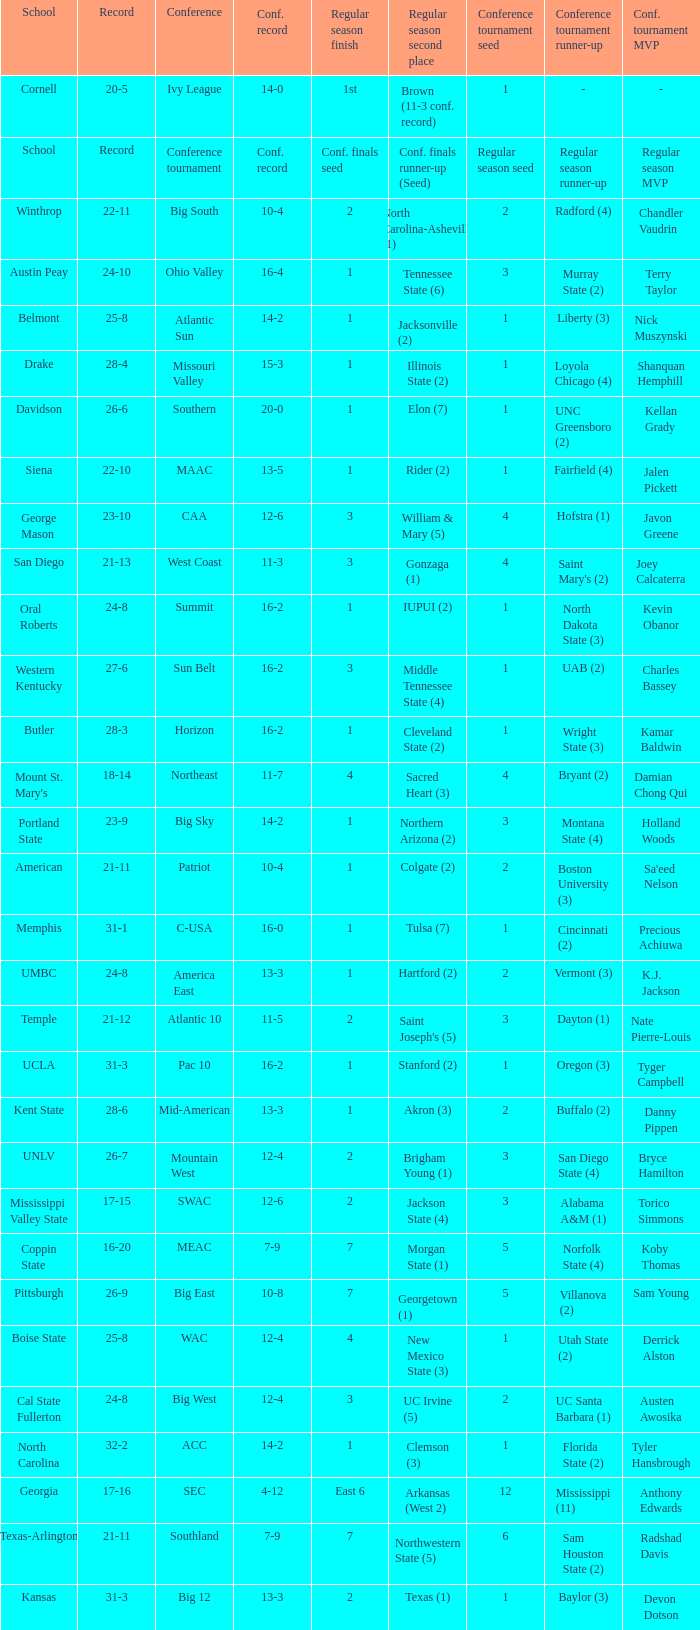For teams in the Sun Belt conference, what is the conference record? 16-2. 